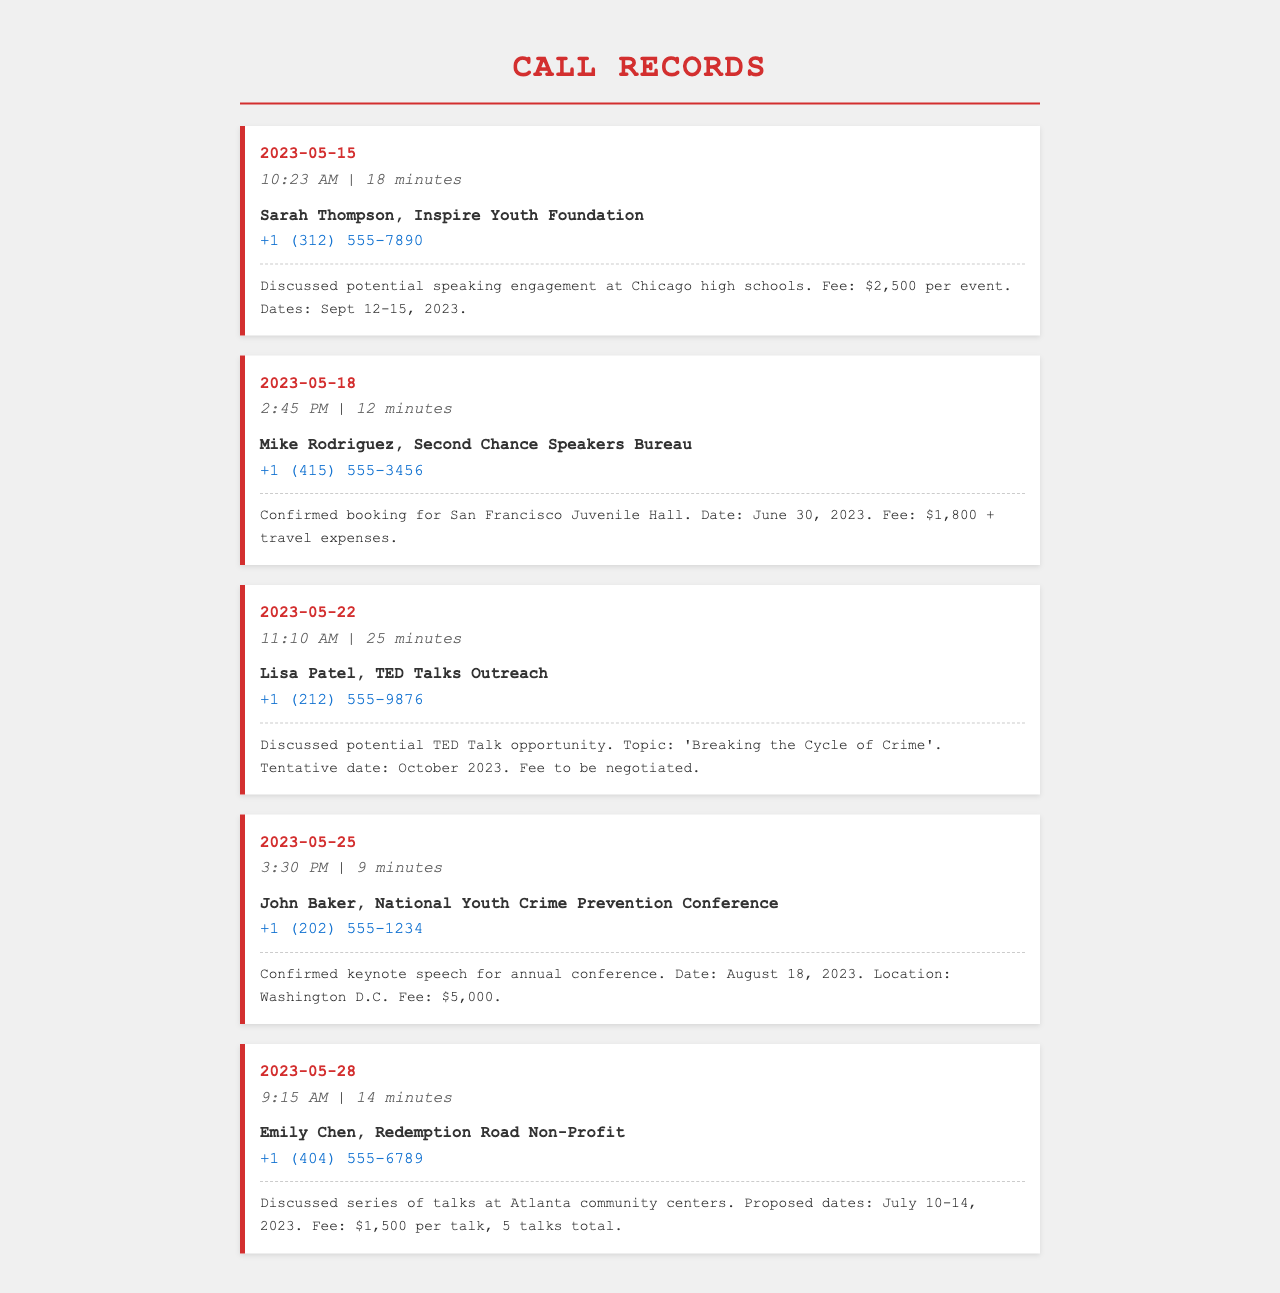What is the date of the first call? The first call in the document is dated May 15, 2023.
Answer: May 15, 2023 Who was the contact for the second call? The second call was made to Mike Rodriguez from Second Chance Speakers Bureau.
Answer: Mike Rodriguez What is the fee for the keynote speech at the National Youth Crime Prevention Conference? The fee for the keynote speech is mentioned in the call notes for John Baker, which is $5,000.
Answer: $5,000 How many talks were discussed for the Atlanta community centers? The discussion included a series of 5 talks at the Atlanta community centers.
Answer: 5 talks What is the tentative date for the TED Talk opportunity? The tentative date for the TED Talk opportunity discussed with Lisa Patel is October 2023.
Answer: October 2023 Which organization is associated with the call on May 25, 2023? The organization associated with the call on May 25, 2023, is the National Youth Crime Prevention Conference.
Answer: National Youth Crime Prevention Conference What is the call duration of the discussion with Emily Chen? The call duration with Emily Chen is 14 minutes.
Answer: 14 minutes What was the proposed date range for talks at Chicago high schools? The proposed dates for talks at Chicago high schools were September 12-15, 2023.
Answer: September 12-15, 2023 